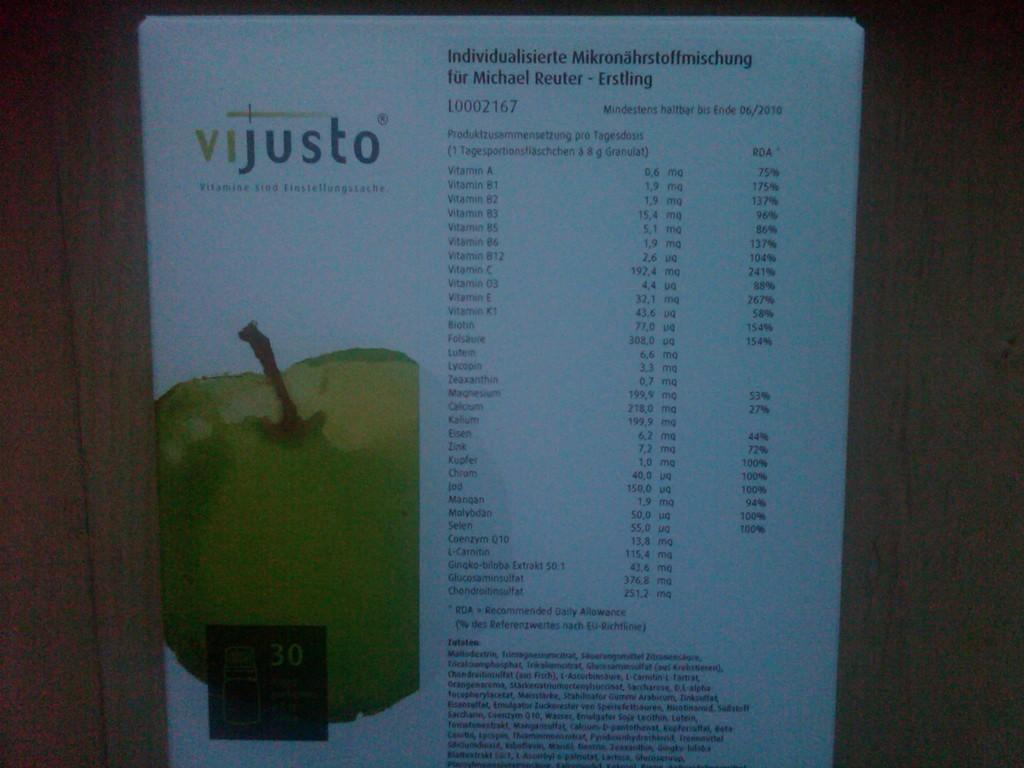<image>
Give a short and clear explanation of the subsequent image. Vijusto Individualisierte Mikronahrsstoffmischung fur Michael Reuter- Erstling vitamin paper. 